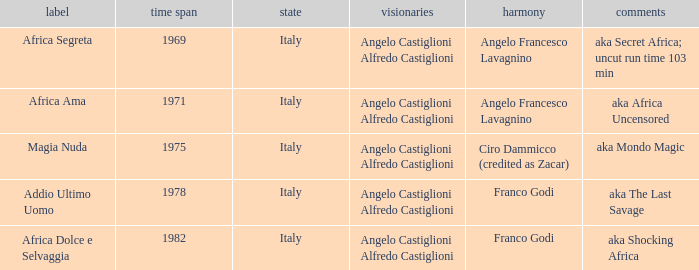Which music has the notes of AKA Africa Uncensored? Angelo Francesco Lavagnino. 